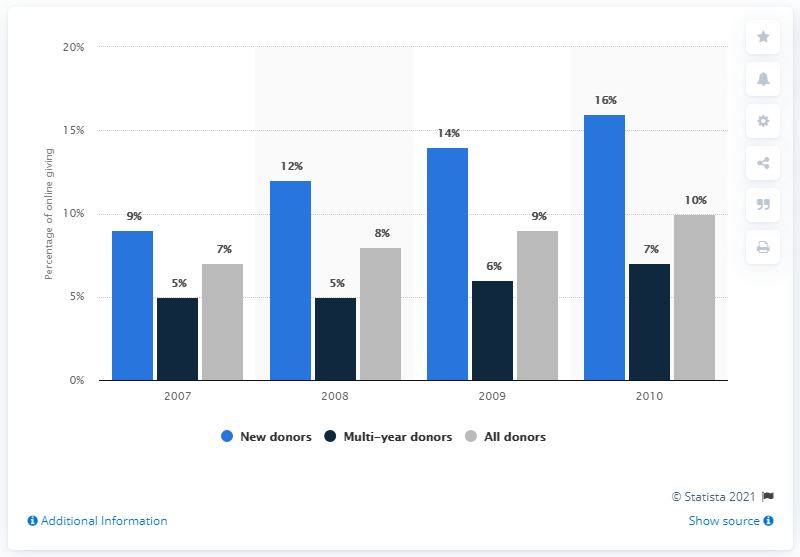Mention a couple of crucial points in this snapshot. In 2009, approximately 6% of donors were multi-year donors. The total percentage that lies between 11% and 15% is 26%. 